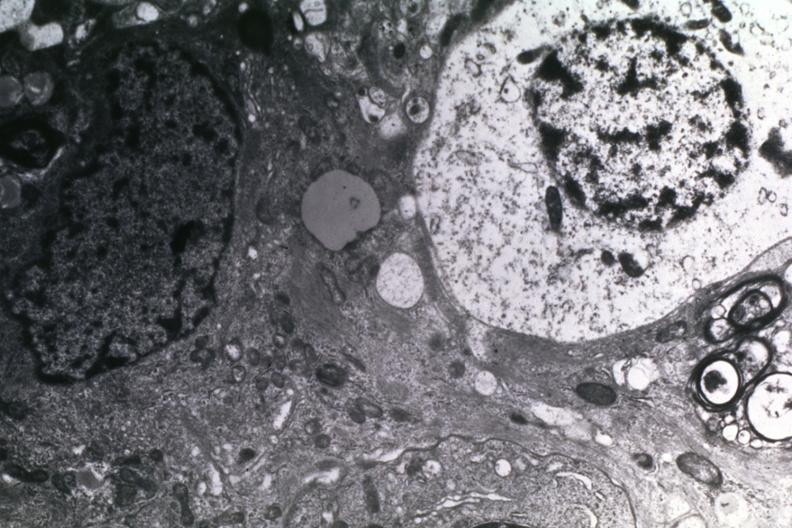s sac present?
Answer the question using a single word or phrase. No 